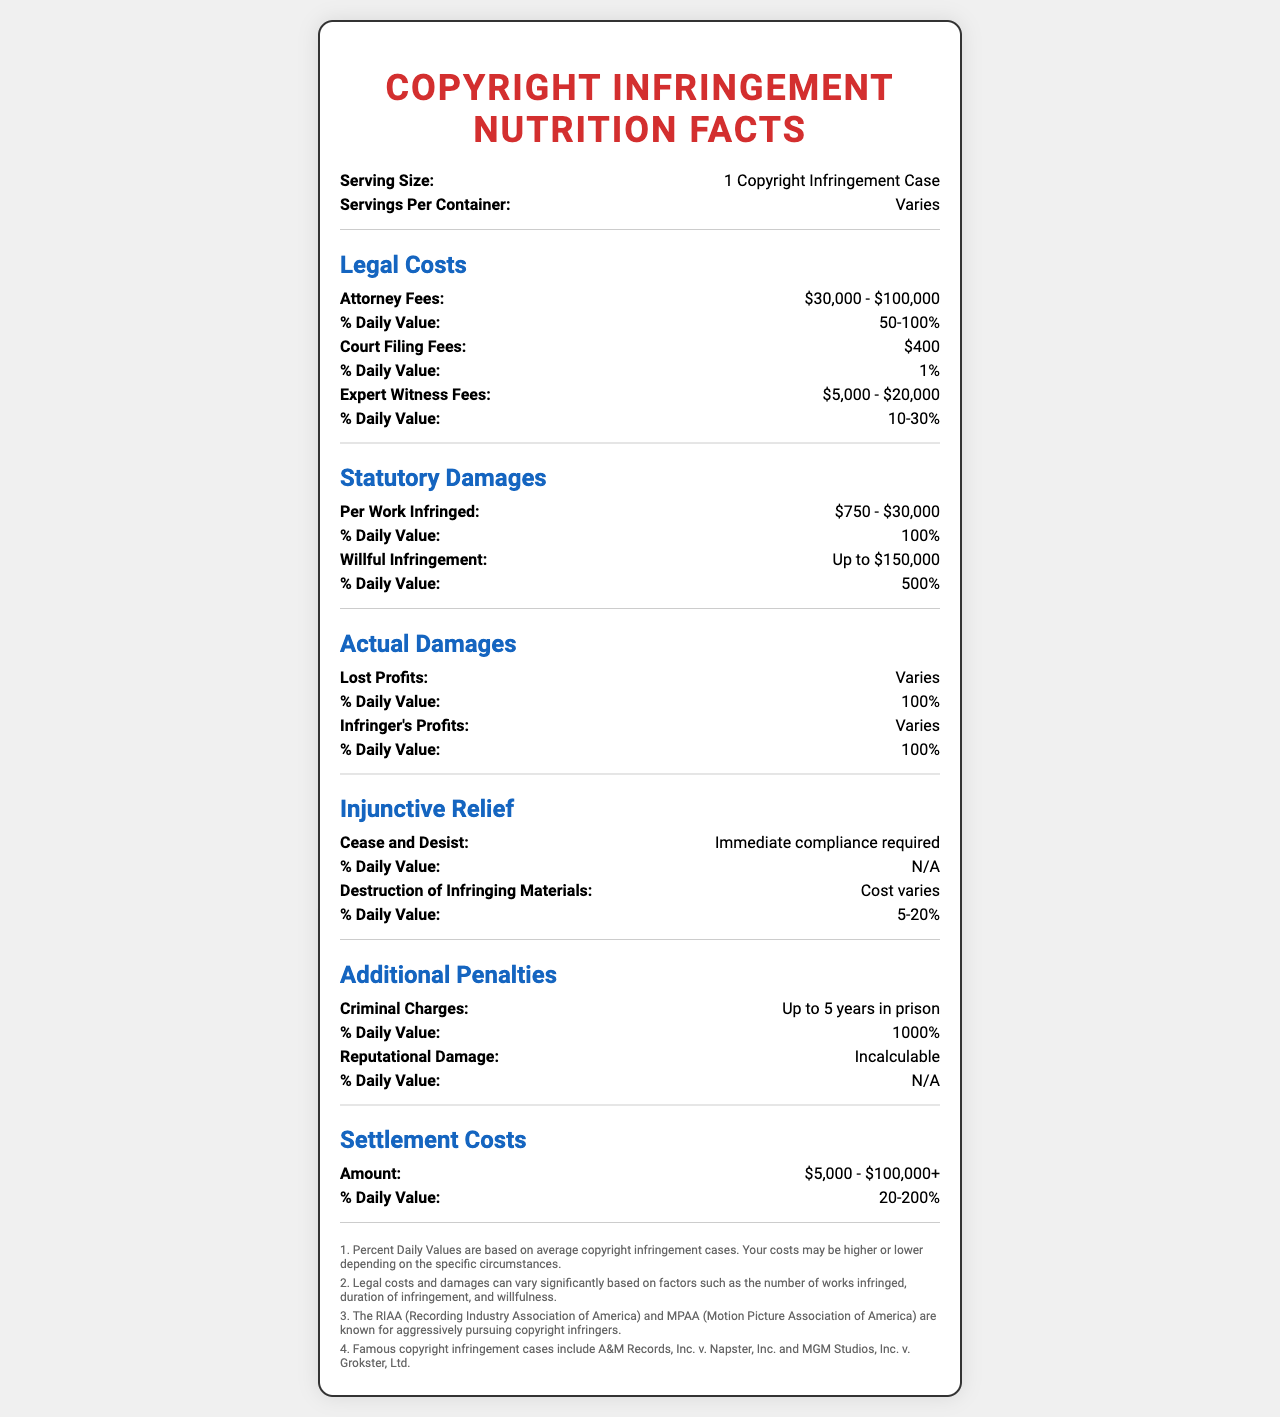what is the serving size indicated on the document? The serving size is given as "1 Copyright Infringement Case" at the top of the document.
Answer: 1 Copyright Infringement Case what are the attorney fees for a copyright infringement case? The attorney fees are listed under the "Legal Costs" section with a range of $30,000 to $100,000.
Answer: $30,000 - $100,000 what is the daily value percentage for expert witness fees? The daily value percentage for expert witness fees is provided as "10-30%" under the "Legal Costs" section.
Answer: 10-30% how much can statutory damages be for willful infringement? In the "Statutory Damages" section, the amount for willful infringement is stated as "Up to $150,000".
Answer: Up to $150,000 are criminal charges an additional penalty? Under the "Additional Penalties" section, criminal charges are listed as an additional penalty with a detailed description.
Answer: Yes who are known for aggressively pursuing copyright infringers? This information is available in the footnotes at the bottom of the document.
Answer: RIAA (Recording Industry Association of America) and MPAA (Motion Picture Association of America) how many years in prison can someone face for criminal charges? The "Additional Penalties" section notes that criminal charges can lead to "Up to 5 years in prison".
Answer: Up to 5 years what does the section on injunctive relief include? The "Injunctive Relief" section lists "Cease and Desist" and "Destruction of Infringing Materials" with respective details.
Answer: Cease and Desist, Destruction of Infringing Materials what is the potential reputational damage for copyright infringement? The document states that the reputational damage is "Incalculable" under the "Additional Penalties" section.
Answer: Incalculable how many footnotes are included in the document? There are 4 footnotes listed at the bottom of the document.
Answer: 4 what is the approximate range of settlement costs for copyright infringement cases? A. $1,000 - $50,000 B. $5,000 - $100,000+ C. $10,000 - $200,000 The "Settlement Costs" section specifies the amount as "$5,000 - $100,000+".
Answer: B how much can court filing fees amount to in a copyright infringement case? A. $200 B. $400 C. $1,000 D. $5,000 The document indicates that the court filing fees are "$400" under the "Legal Costs" section.
Answer: B in famous copyright infringement cases, who were the plaintiffs in A&M Records, Inc. v. Napster, Inc.? The document does not provide the specific plaintiffs involved in the mentioned cases.
Answer: Cannot be determined what additional penalties might someone face for copyright infringement? A. Injunctive Relief B. Criminal Charges C. Actual Damages D. All of the above The document lists multiple penalties including injunctive relief, criminal charges, and actual damages.
Answer: D summarize the main idea of the document The primary focus of the document is to provide a comprehensive overview of the financial and legal repercussions of engaging in copyright infringement, presented in the format of a "Nutrition Facts" label for easier consumption and understanding.
Answer: The document outlines the potential legal costs, penalties, and damages associated with copyright infringement cases, including attorney fees, court costs, statutory and actual damages, injunctive relief, and additional penalties such as criminal charges and reputational harm. 